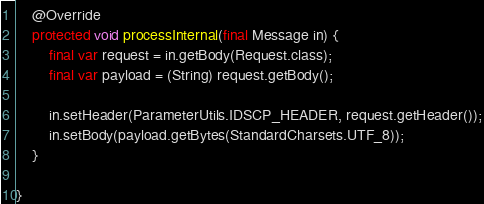Convert code to text. <code><loc_0><loc_0><loc_500><loc_500><_Java_>    @Override
    protected void processInternal(final Message in) {
        final var request = in.getBody(Request.class);
        final var payload = (String) request.getBody();

        in.setHeader(ParameterUtils.IDSCP_HEADER, request.getHeader());
        in.setBody(payload.getBytes(StandardCharsets.UTF_8));
    }

}
</code> 